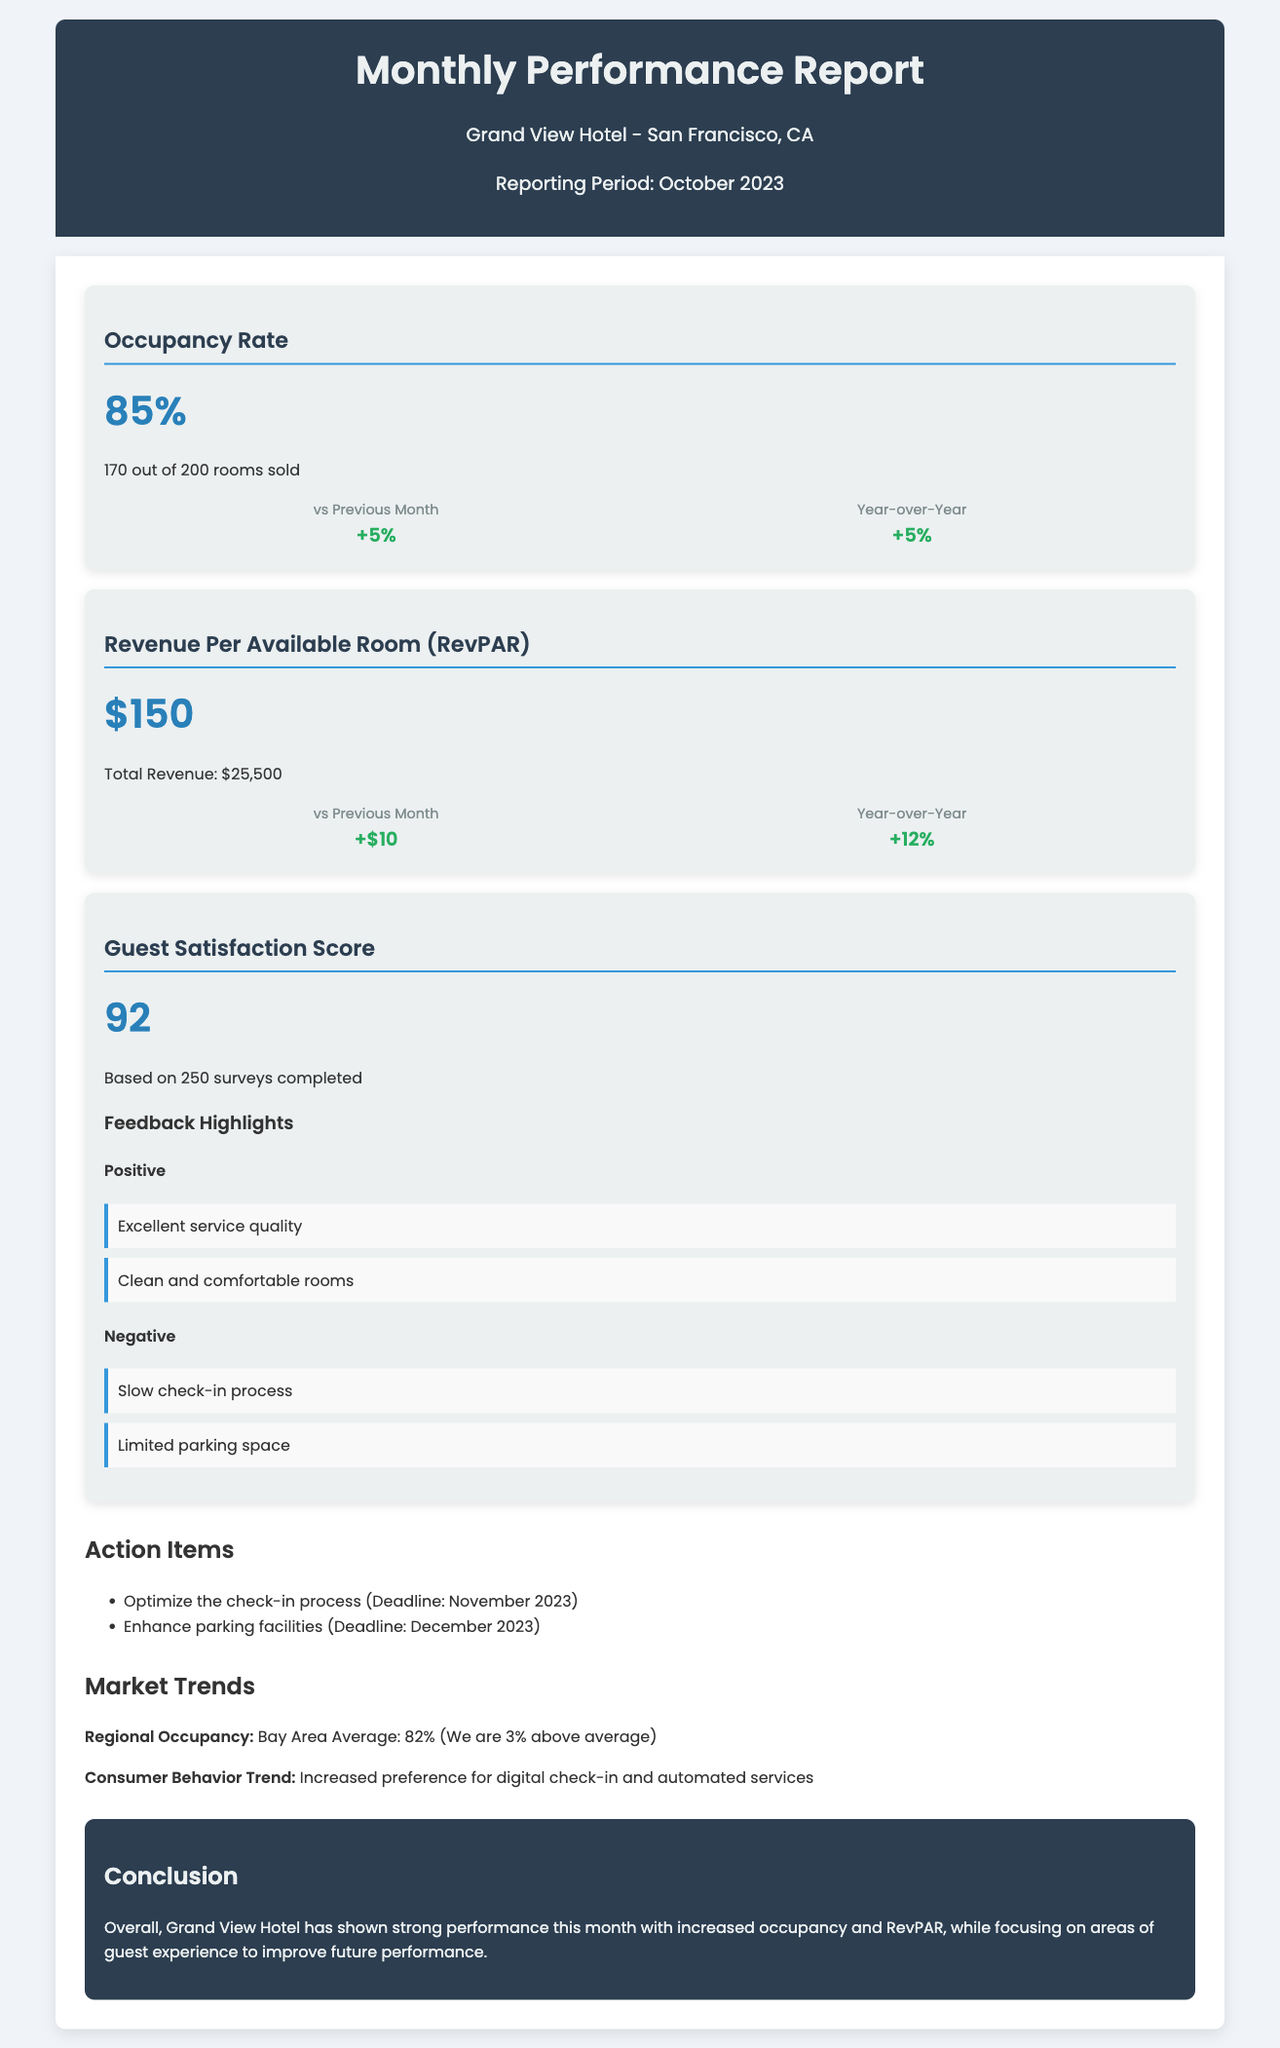What is the occupancy rate? The occupancy rate is provided in the document as a key metric for hotel performance, which is 85%.
Answer: 85% What was the total revenue for the month? The total revenue is mentioned in the context of RevPAR, stated as $25,500.
Answer: $25,500 How many rooms were sold? The document specifies that 170 out of 200 rooms were sold, which contributes to the occupancy rate calculation.
Answer: 170 out of 200 What is the guest satisfaction score? The guest satisfaction score is provided as a metric reflecting guest feedback, noted as 92.
Answer: 92 What is the percentage increase in RevPAR compared to the previous month? The document mentions that RevPAR had an increase of $10, indicating a rise in performance, expressed as +$10 compared to the last month.
Answer: +$10 What feedback did guests provide about service quality? The document lists positive feedback that includes "Excellent service quality," reflecting guests' satisfaction.
Answer: Excellent service quality What action item is related to the check-in process? The document outlines an action item to "Optimize the check-in process" with a specified deadline of November 2023.
Answer: Optimize the check-in process How much above average is the occupancy compared to the Bay Area average? The report compares the occupancy of the hotel to the Bay Area average of 82% and states that the hotel is 3% above this average.
Answer: 3% What is the notable consumer behavior trend mentioned? The document highlights a market trend regarding consumer preferences focusing on "Increased preference for digital check-in and automated services."
Answer: Increased preference for digital check-in and automated services What conclusions are drawn about the hotel's performance? The conclusion summarizes overall performance by mentioning the hotel showed "strong performance this month," highlighting increased occupancy and RevPAR.
Answer: Strong performance this month 